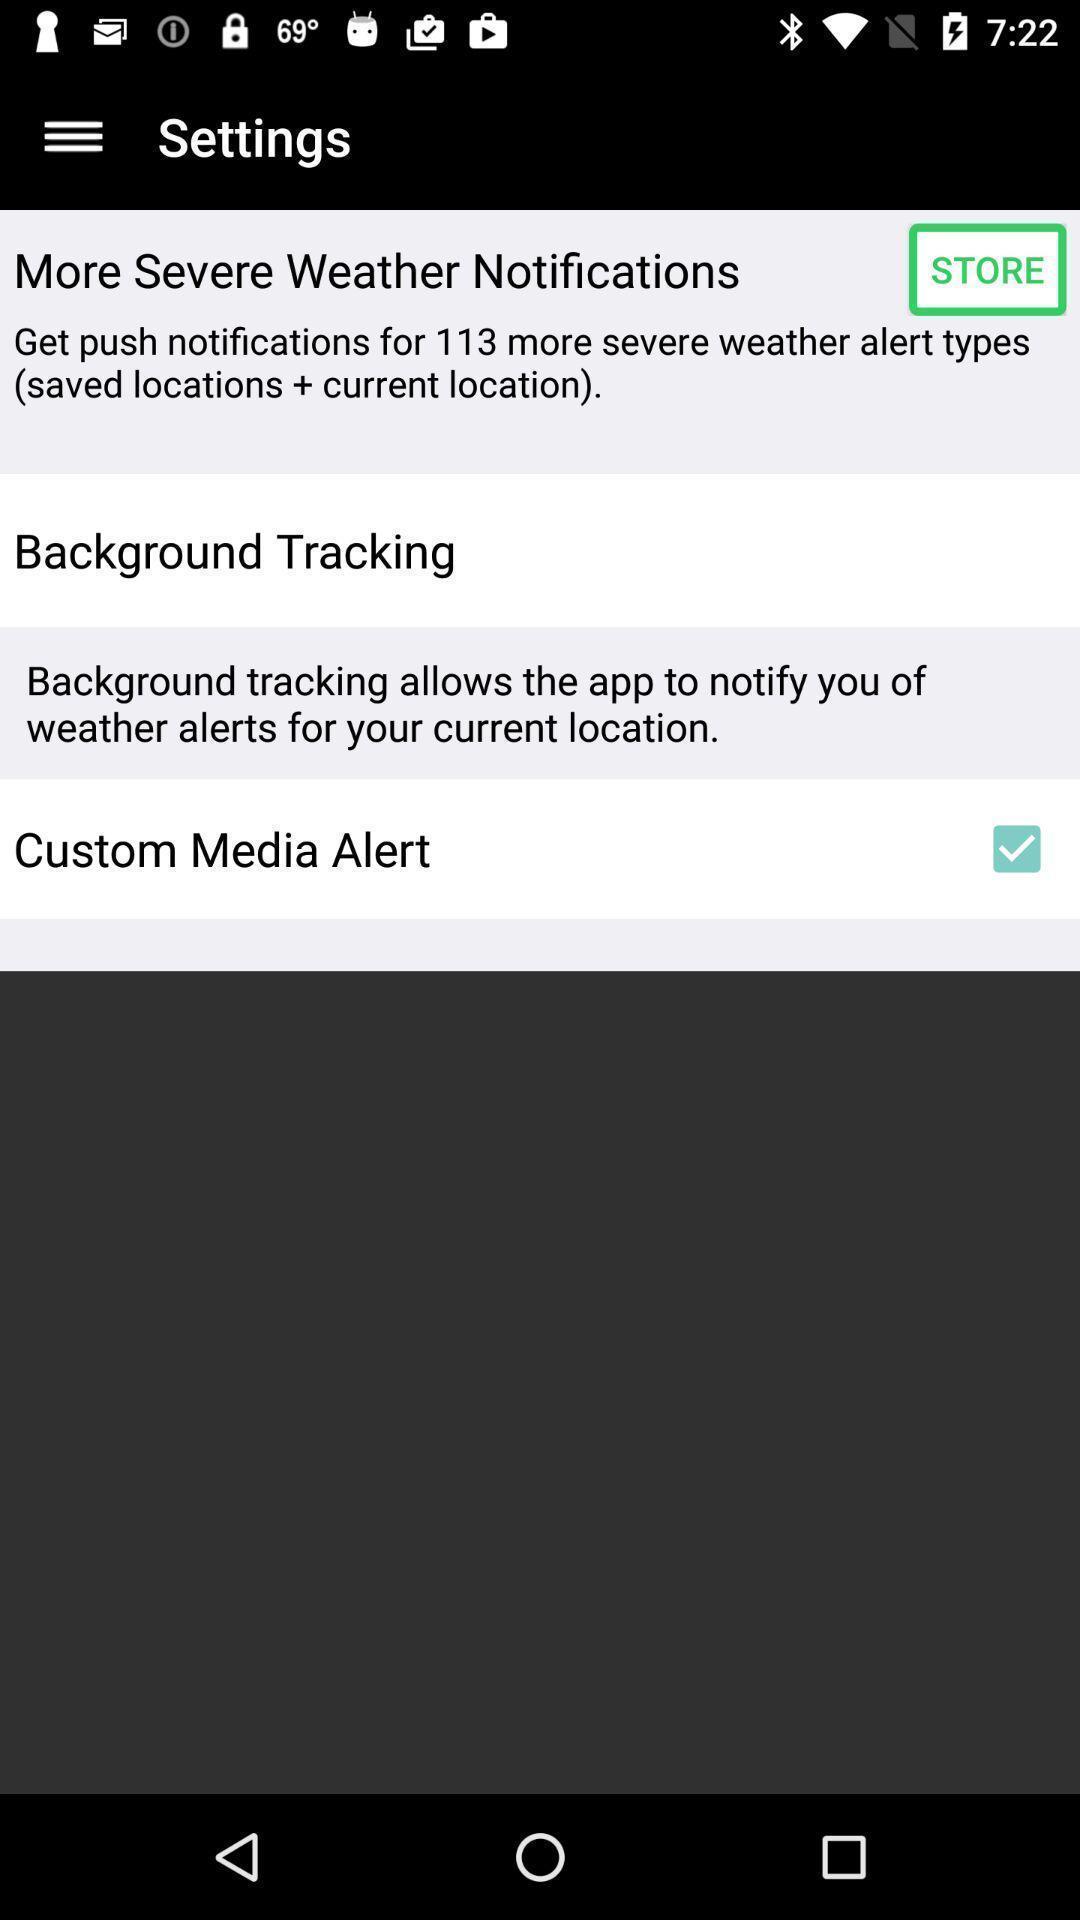Describe this image in words. Settings page. 